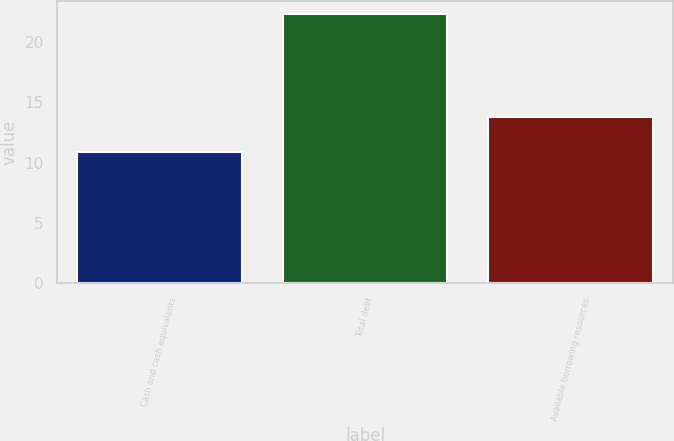<chart> <loc_0><loc_0><loc_500><loc_500><bar_chart><fcel>Cash and cash equivalents<fcel>Total debt<fcel>Available borrowing resources<nl><fcel>10.9<fcel>22.3<fcel>13.8<nl></chart> 